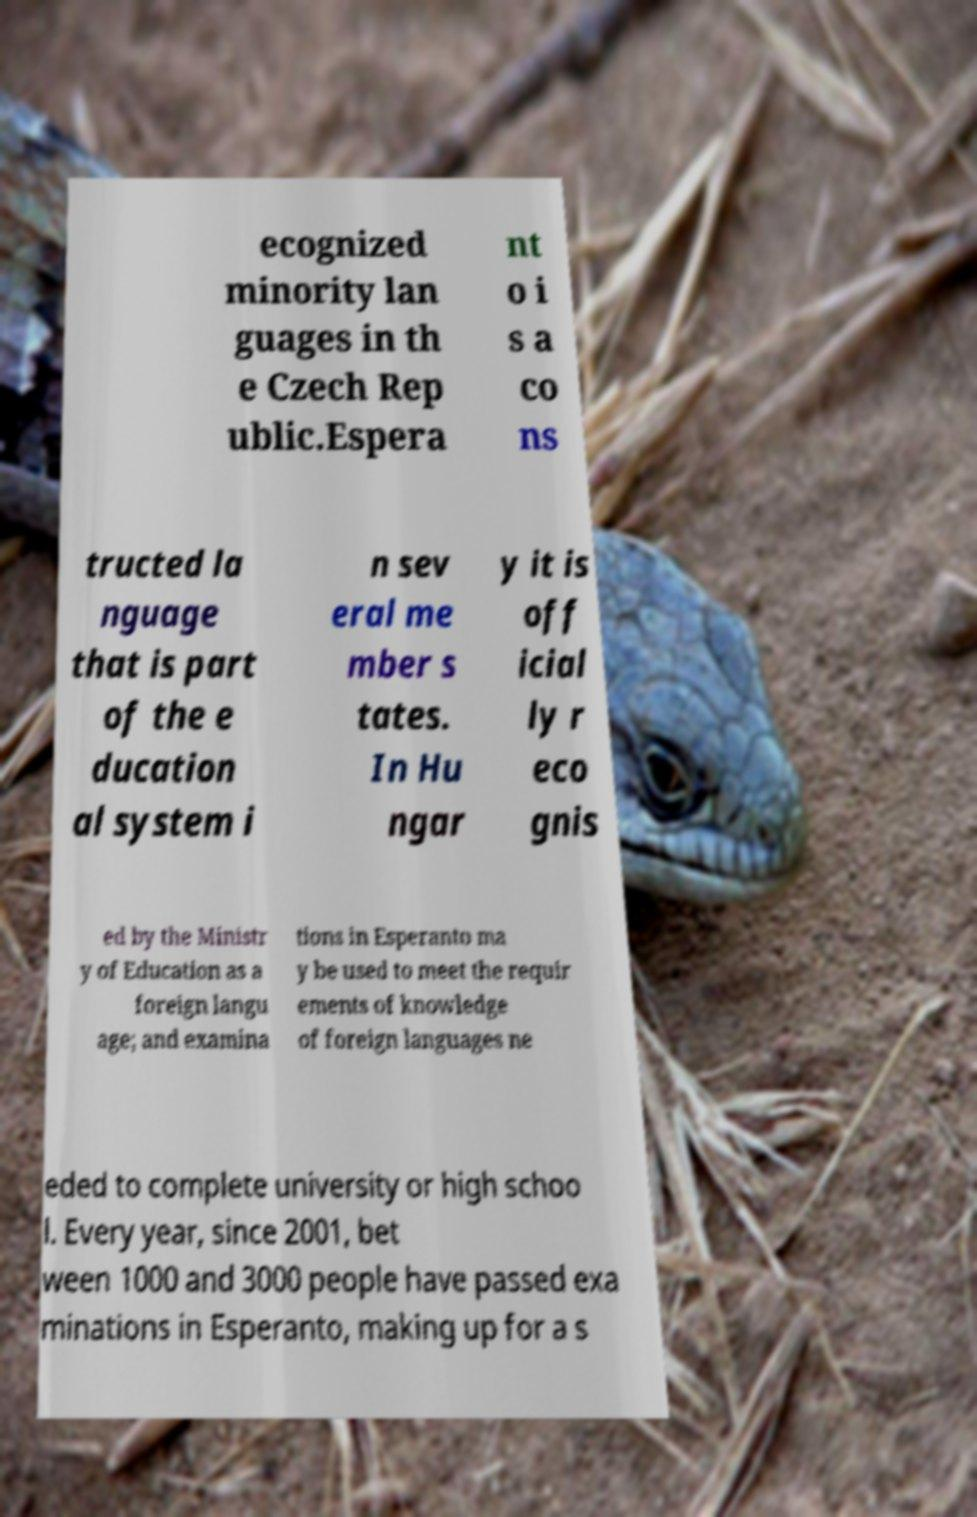Please identify and transcribe the text found in this image. ecognized minority lan guages in th e Czech Rep ublic.Espera nt o i s a co ns tructed la nguage that is part of the e ducation al system i n sev eral me mber s tates. In Hu ngar y it is off icial ly r eco gnis ed by the Ministr y of Education as a foreign langu age; and examina tions in Esperanto ma y be used to meet the requir ements of knowledge of foreign languages ne eded to complete university or high schoo l. Every year, since 2001, bet ween 1000 and 3000 people have passed exa minations in Esperanto, making up for a s 